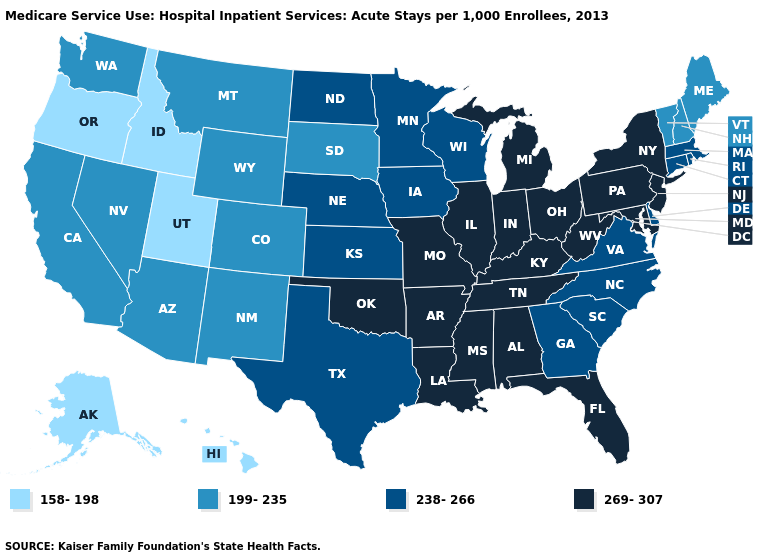Which states have the highest value in the USA?
Write a very short answer. Alabama, Arkansas, Florida, Illinois, Indiana, Kentucky, Louisiana, Maryland, Michigan, Mississippi, Missouri, New Jersey, New York, Ohio, Oklahoma, Pennsylvania, Tennessee, West Virginia. Does Idaho have the lowest value in the USA?
Short answer required. Yes. Name the states that have a value in the range 269-307?
Short answer required. Alabama, Arkansas, Florida, Illinois, Indiana, Kentucky, Louisiana, Maryland, Michigan, Mississippi, Missouri, New Jersey, New York, Ohio, Oklahoma, Pennsylvania, Tennessee, West Virginia. Name the states that have a value in the range 269-307?
Concise answer only. Alabama, Arkansas, Florida, Illinois, Indiana, Kentucky, Louisiana, Maryland, Michigan, Mississippi, Missouri, New Jersey, New York, Ohio, Oklahoma, Pennsylvania, Tennessee, West Virginia. Among the states that border Massachusetts , which have the highest value?
Be succinct. New York. Name the states that have a value in the range 158-198?
Be succinct. Alaska, Hawaii, Idaho, Oregon, Utah. Name the states that have a value in the range 269-307?
Short answer required. Alabama, Arkansas, Florida, Illinois, Indiana, Kentucky, Louisiana, Maryland, Michigan, Mississippi, Missouri, New Jersey, New York, Ohio, Oklahoma, Pennsylvania, Tennessee, West Virginia. What is the value of Louisiana?
Give a very brief answer. 269-307. Name the states that have a value in the range 199-235?
Concise answer only. Arizona, California, Colorado, Maine, Montana, Nevada, New Hampshire, New Mexico, South Dakota, Vermont, Washington, Wyoming. What is the value of Kentucky?
Be succinct. 269-307. Name the states that have a value in the range 269-307?
Give a very brief answer. Alabama, Arkansas, Florida, Illinois, Indiana, Kentucky, Louisiana, Maryland, Michigan, Mississippi, Missouri, New Jersey, New York, Ohio, Oklahoma, Pennsylvania, Tennessee, West Virginia. Name the states that have a value in the range 199-235?
Quick response, please. Arizona, California, Colorado, Maine, Montana, Nevada, New Hampshire, New Mexico, South Dakota, Vermont, Washington, Wyoming. What is the highest value in states that border New Jersey?
Keep it brief. 269-307. 